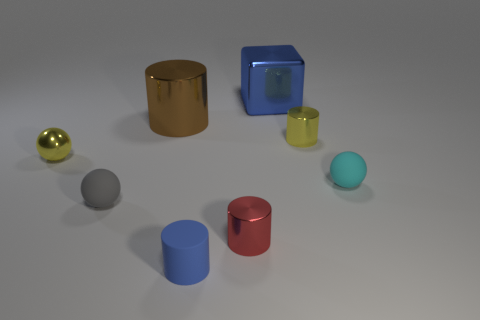There is a big cylinder that is made of the same material as the yellow sphere; what is its color?
Make the answer very short. Brown. How many cubes have the same material as the tiny yellow cylinder?
Provide a short and direct response. 1. Do the large metal thing that is on the right side of the blue matte cylinder and the big shiny cylinder have the same color?
Make the answer very short. No. How many other small gray matte objects have the same shape as the tiny gray thing?
Your answer should be compact. 0. Are there an equal number of tiny matte balls that are right of the small yellow metal cylinder and cyan matte spheres?
Offer a terse response. Yes. There is another metal object that is the same size as the brown thing; what color is it?
Give a very brief answer. Blue. Is there a large thing that has the same shape as the small blue thing?
Your response must be concise. Yes. The big thing to the right of the metal cylinder that is on the left side of the cylinder in front of the small red shiny cylinder is made of what material?
Keep it short and to the point. Metal. How many other objects are there of the same size as the cyan thing?
Offer a very short reply. 5. What is the color of the metallic block?
Offer a terse response. Blue. 